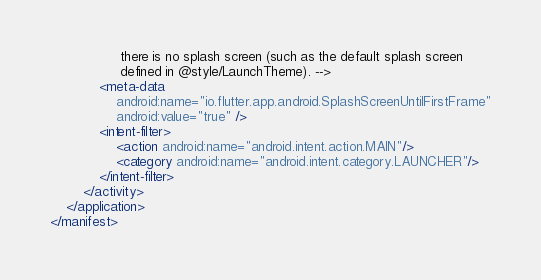Convert code to text. <code><loc_0><loc_0><loc_500><loc_500><_XML_>                 there is no splash screen (such as the default splash screen
                 defined in @style/LaunchTheme). -->
            <meta-data
                android:name="io.flutter.app.android.SplashScreenUntilFirstFrame"
                android:value="true" />
            <intent-filter>
                <action android:name="android.intent.action.MAIN"/>
                <category android:name="android.intent.category.LAUNCHER"/>
            </intent-filter>
        </activity>
    </application>
</manifest>
</code> 